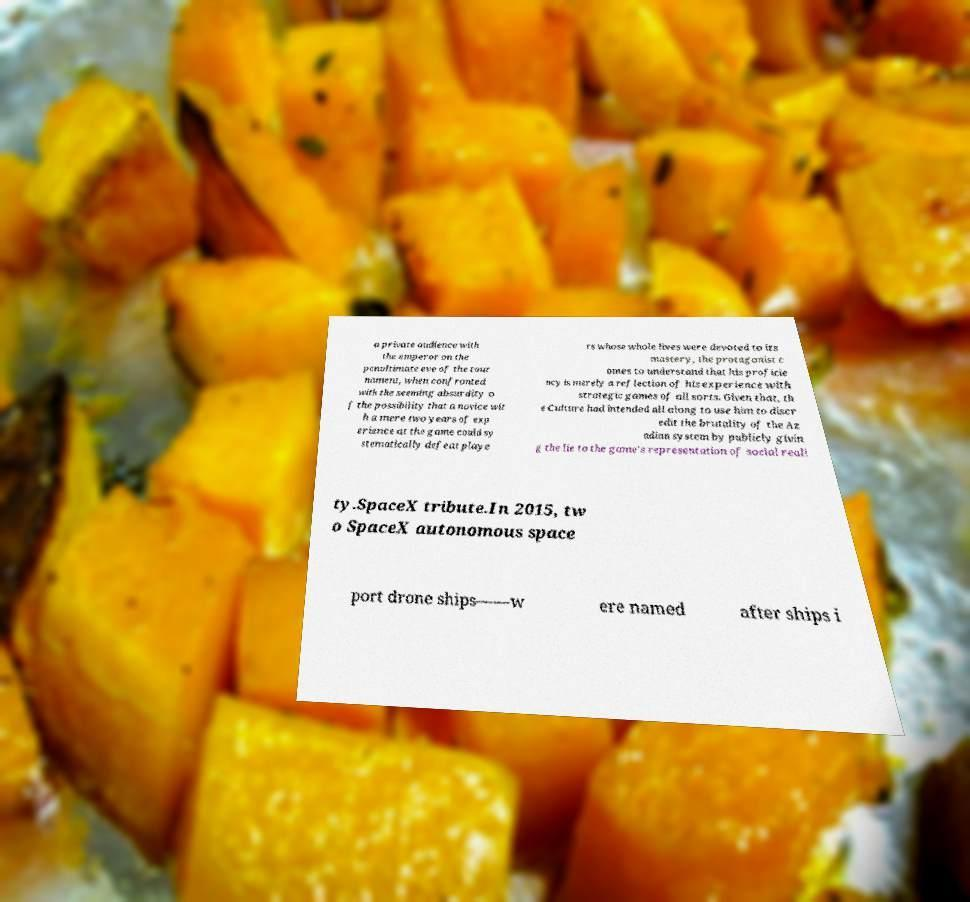What messages or text are displayed in this image? I need them in a readable, typed format. a private audience with the emperor on the penultimate eve of the tour nament, when confronted with the seeming absurdity o f the possibility that a novice wit h a mere two years of exp erience at the game could sy stematically defeat playe rs whose whole lives were devoted to its mastery, the protagonist c omes to understand that his proficie ncy is merely a reflection of his experience with strategic games of all sorts. Given that, th e Culture had intended all along to use him to discr edit the brutality of the Az adian system by publicly givin g the lie to the game's representation of social reali ty.SpaceX tribute.In 2015, tw o SpaceX autonomous space port drone ships——w ere named after ships i 